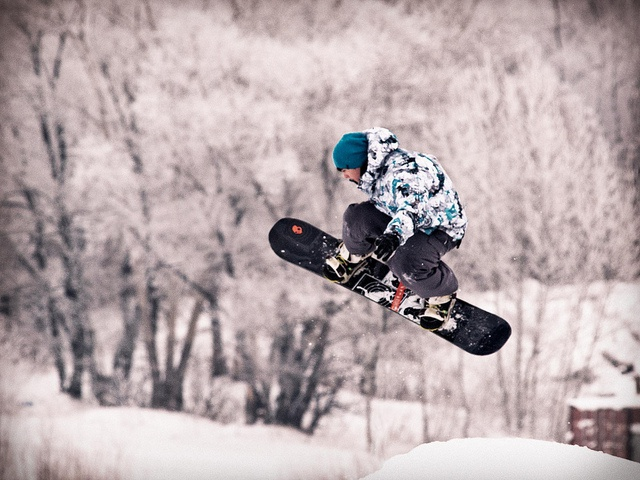Describe the objects in this image and their specific colors. I can see people in black, lavender, gray, and darkgray tones and snowboard in black, gray, lightgray, and darkgray tones in this image. 